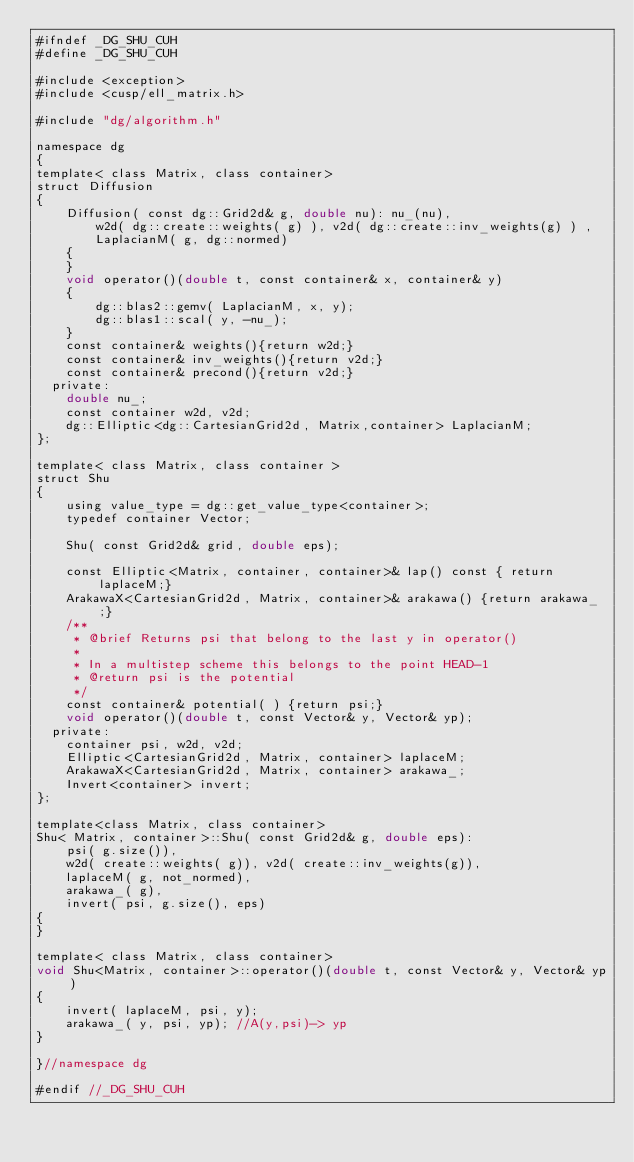<code> <loc_0><loc_0><loc_500><loc_500><_Cuda_>#ifndef _DG_SHU_CUH
#define _DG_SHU_CUH

#include <exception>
#include <cusp/ell_matrix.h>

#include "dg/algorithm.h"

namespace dg
{
template< class Matrix, class container>
struct Diffusion
{
    Diffusion( const dg::Grid2d& g, double nu): nu_(nu),
        w2d( dg::create::weights( g) ), v2d( dg::create::inv_weights(g) ) ,
        LaplacianM( g, dg::normed)
    { 
    }
    void operator()(double t, const container& x, container& y)
    {
        dg::blas2::gemv( LaplacianM, x, y);
        dg::blas1::scal( y, -nu_);
    }
    const container& weights(){return w2d;}
    const container& inv_weights(){return v2d;}
    const container& precond(){return v2d;}
  private:
    double nu_;
    const container w2d, v2d;
    dg::Elliptic<dg::CartesianGrid2d, Matrix,container> LaplacianM;
};

template< class Matrix, class container >
struct Shu 
{
    using value_type = dg::get_value_type<container>;
    typedef container Vector;

    Shu( const Grid2d& grid, double eps);

    const Elliptic<Matrix, container, container>& lap() const { return laplaceM;}
    ArakawaX<CartesianGrid2d, Matrix, container>& arakawa() {return arakawa_;}
    /**
     * @brief Returns psi that belong to the last y in operator()
     *
     * In a multistep scheme this belongs to the point HEAD-1
     * @return psi is the potential
     */
    const container& potential( ) {return psi;}
    void operator()(double t, const Vector& y, Vector& yp);
  private:
    container psi, w2d, v2d;
    Elliptic<CartesianGrid2d, Matrix, container> laplaceM;
    ArakawaX<CartesianGrid2d, Matrix, container> arakawa_; 
    Invert<container> invert;
};

template<class Matrix, class container>
Shu< Matrix, container>::Shu( const Grid2d& g, double eps): 
    psi( g.size()),
    w2d( create::weights( g)), v2d( create::inv_weights(g)),  
    laplaceM( g, not_normed),
    arakawa_( g), 
    invert( psi, g.size(), eps)
{
}

template< class Matrix, class container>
void Shu<Matrix, container>::operator()(double t, const Vector& y, Vector& yp)
{
    invert( laplaceM, psi, y);
    arakawa_( y, psi, yp); //A(y,psi)-> yp
}

}//namespace dg

#endif //_DG_SHU_CUH
</code> 